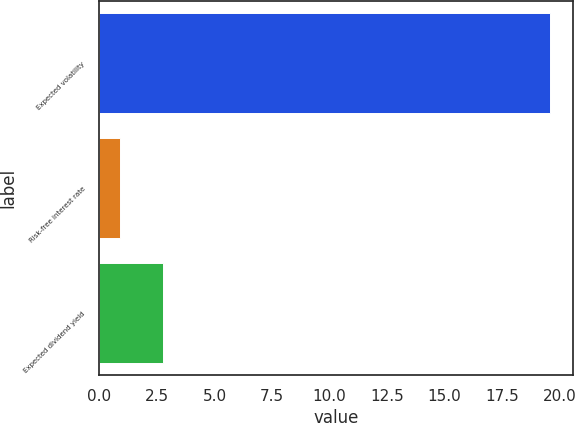<chart> <loc_0><loc_0><loc_500><loc_500><bar_chart><fcel>Expected volatility<fcel>Risk-free interest rate<fcel>Expected dividend yield<nl><fcel>19.6<fcel>0.9<fcel>2.77<nl></chart> 